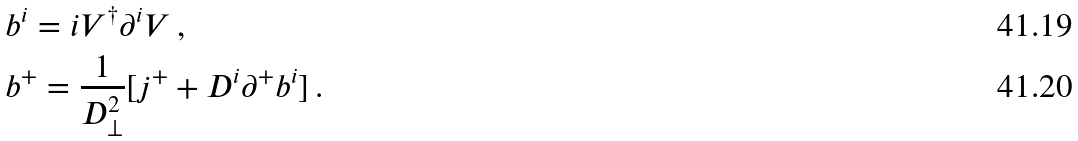<formula> <loc_0><loc_0><loc_500><loc_500>& b ^ { i } = i V ^ { \dagger } \partial ^ { i } V \, , \\ & b ^ { + } = \frac { 1 } { D ^ { 2 } _ { \perp } } [ j ^ { + } + D ^ { i } \partial ^ { + } b ^ { i } ] \, .</formula> 